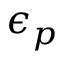<formula> <loc_0><loc_0><loc_500><loc_500>\epsilon _ { p }</formula> 